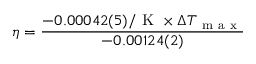<formula> <loc_0><loc_0><loc_500><loc_500>\eta = \frac { - 0 . 0 0 0 4 2 ( 5 ) / K \times \Delta T _ { m a x } } { - 0 . 0 0 1 2 4 ( 2 ) }</formula> 